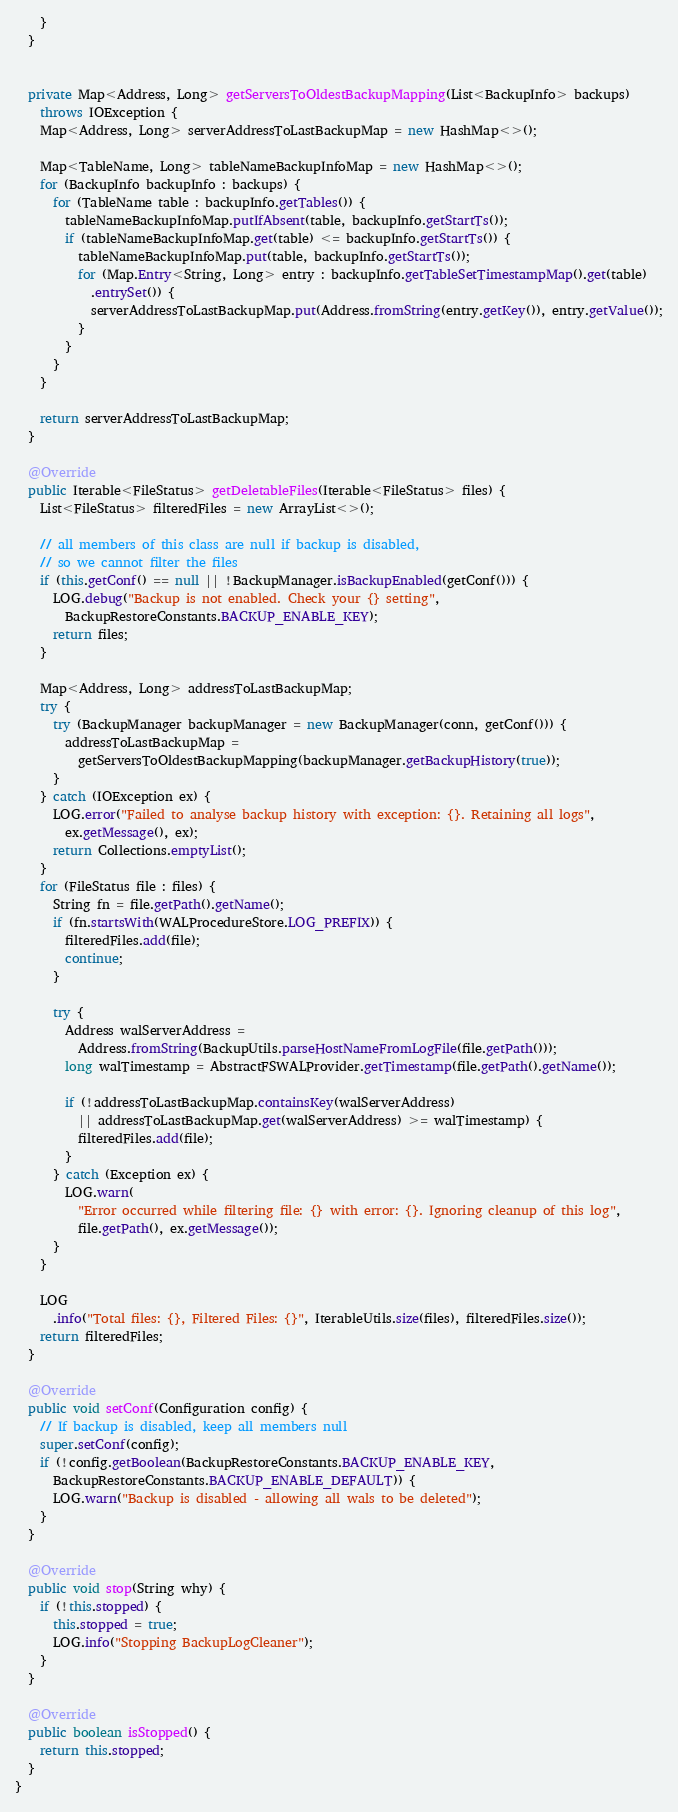Convert code to text. <code><loc_0><loc_0><loc_500><loc_500><_Java_>    }
  }


  private Map<Address, Long> getServersToOldestBackupMapping(List<BackupInfo> backups)
    throws IOException {
    Map<Address, Long> serverAddressToLastBackupMap = new HashMap<>();

    Map<TableName, Long> tableNameBackupInfoMap = new HashMap<>();
    for (BackupInfo backupInfo : backups) {
      for (TableName table : backupInfo.getTables()) {
        tableNameBackupInfoMap.putIfAbsent(table, backupInfo.getStartTs());
        if (tableNameBackupInfoMap.get(table) <= backupInfo.getStartTs()) {
          tableNameBackupInfoMap.put(table, backupInfo.getStartTs());
          for (Map.Entry<String, Long> entry : backupInfo.getTableSetTimestampMap().get(table)
            .entrySet()) {
            serverAddressToLastBackupMap.put(Address.fromString(entry.getKey()), entry.getValue());
          }
        }
      }
    }

    return serverAddressToLastBackupMap;
  }

  @Override
  public Iterable<FileStatus> getDeletableFiles(Iterable<FileStatus> files) {
    List<FileStatus> filteredFiles = new ArrayList<>();

    // all members of this class are null if backup is disabled,
    // so we cannot filter the files
    if (this.getConf() == null || !BackupManager.isBackupEnabled(getConf())) {
      LOG.debug("Backup is not enabled. Check your {} setting",
        BackupRestoreConstants.BACKUP_ENABLE_KEY);
      return files;
    }

    Map<Address, Long> addressToLastBackupMap;
    try {
      try (BackupManager backupManager = new BackupManager(conn, getConf())) {
        addressToLastBackupMap =
          getServersToOldestBackupMapping(backupManager.getBackupHistory(true));
      }
    } catch (IOException ex) {
      LOG.error("Failed to analyse backup history with exception: {}. Retaining all logs",
        ex.getMessage(), ex);
      return Collections.emptyList();
    }
    for (FileStatus file : files) {
      String fn = file.getPath().getName();
      if (fn.startsWith(WALProcedureStore.LOG_PREFIX)) {
        filteredFiles.add(file);
        continue;
      }

      try {
        Address walServerAddress =
          Address.fromString(BackupUtils.parseHostNameFromLogFile(file.getPath()));
        long walTimestamp = AbstractFSWALProvider.getTimestamp(file.getPath().getName());

        if (!addressToLastBackupMap.containsKey(walServerAddress)
          || addressToLastBackupMap.get(walServerAddress) >= walTimestamp) {
          filteredFiles.add(file);
        }
      } catch (Exception ex) {
        LOG.warn(
          "Error occurred while filtering file: {} with error: {}. Ignoring cleanup of this log",
          file.getPath(), ex.getMessage());
      }
    }

    LOG
      .info("Total files: {}, Filtered Files: {}", IterableUtils.size(files), filteredFiles.size());
    return filteredFiles;
  }

  @Override
  public void setConf(Configuration config) {
    // If backup is disabled, keep all members null
    super.setConf(config);
    if (!config.getBoolean(BackupRestoreConstants.BACKUP_ENABLE_KEY,
      BackupRestoreConstants.BACKUP_ENABLE_DEFAULT)) {
      LOG.warn("Backup is disabled - allowing all wals to be deleted");
    }
  }

  @Override
  public void stop(String why) {
    if (!this.stopped) {
      this.stopped = true;
      LOG.info("Stopping BackupLogCleaner");
    }
  }

  @Override
  public boolean isStopped() {
    return this.stopped;
  }
}
</code> 